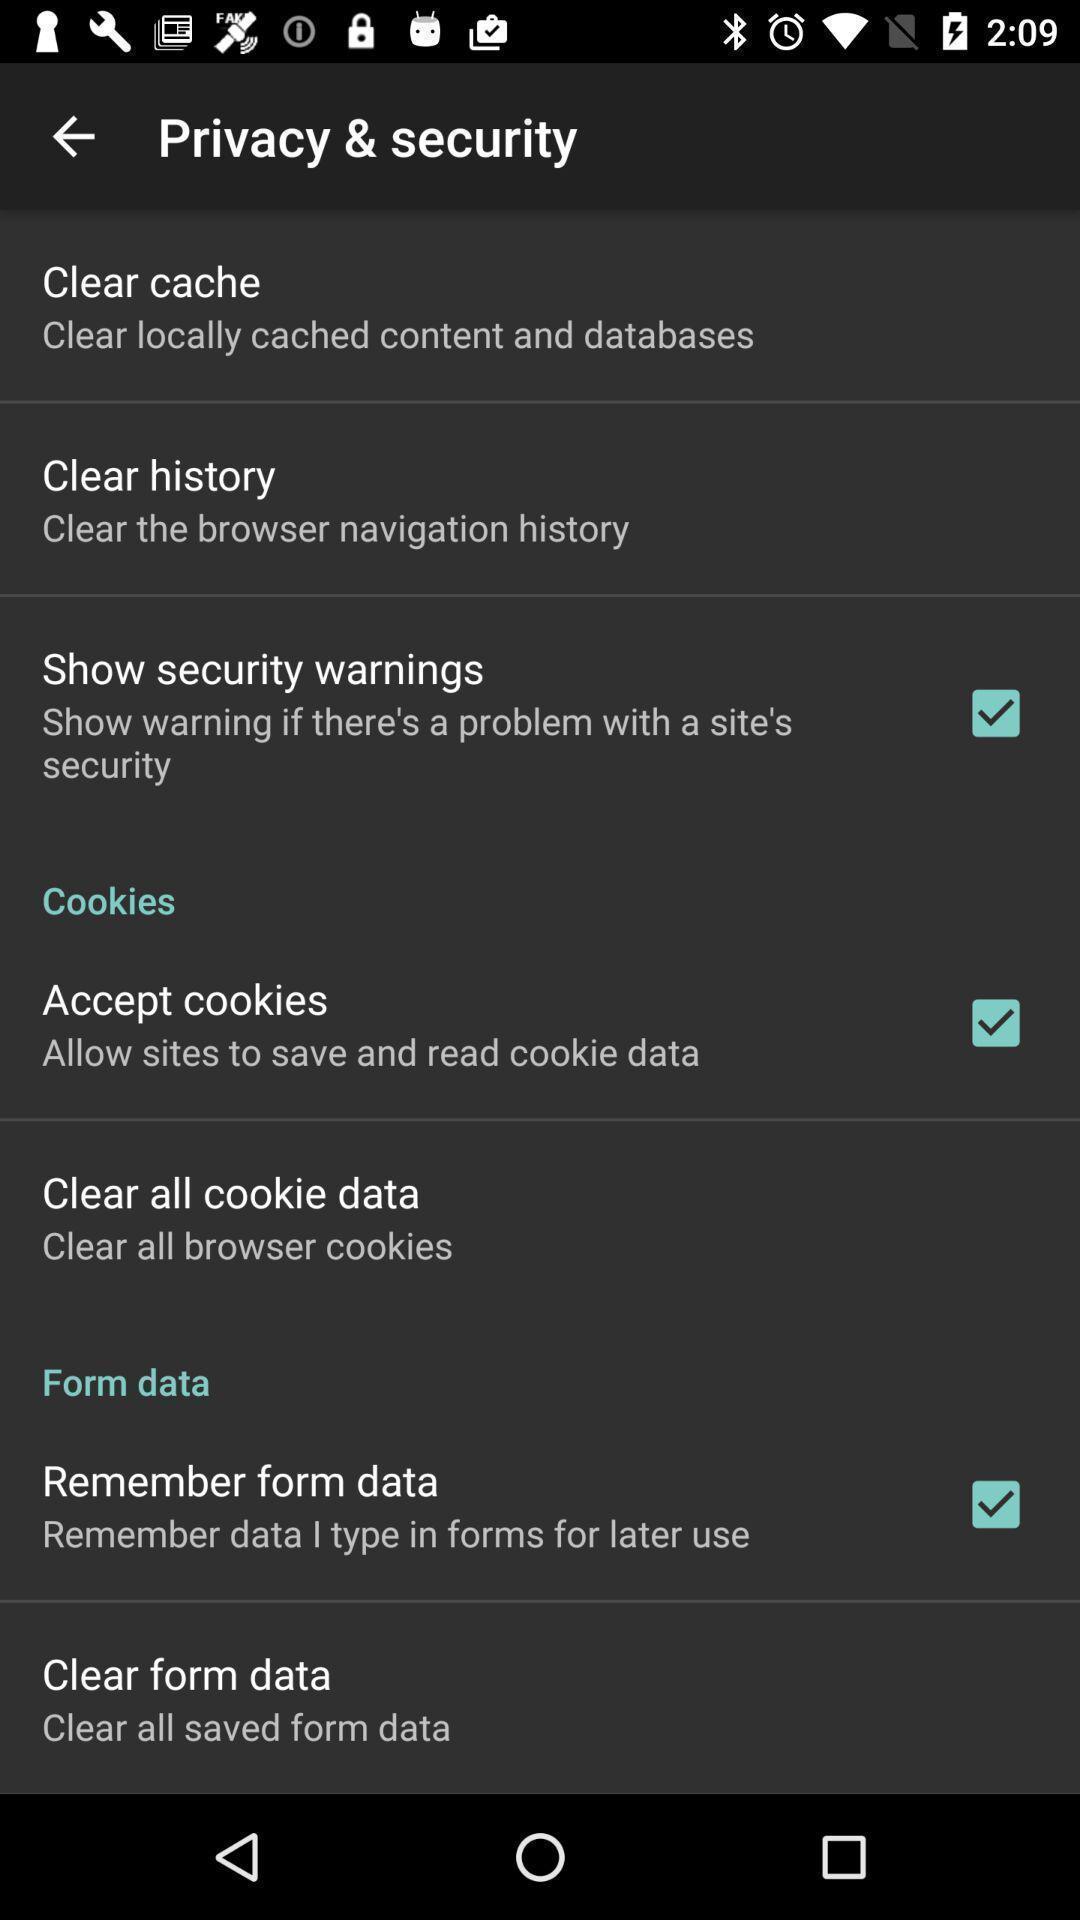Describe this image in words. Settings page. 